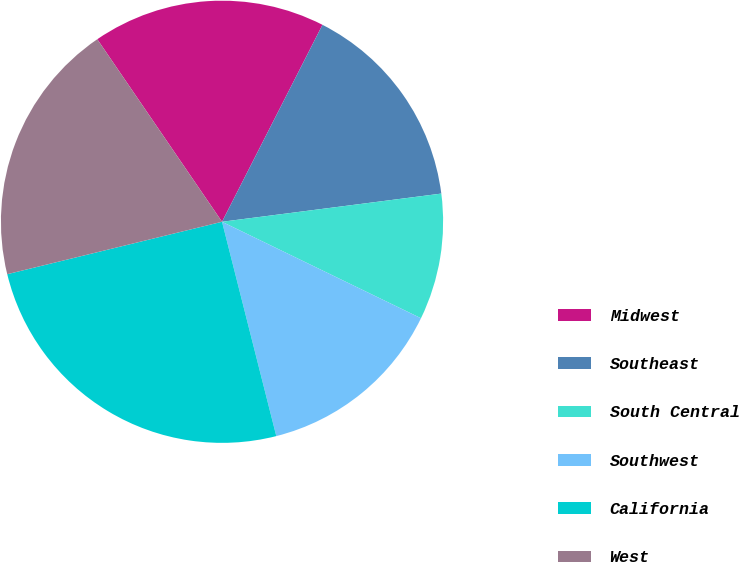<chart> <loc_0><loc_0><loc_500><loc_500><pie_chart><fcel>Midwest<fcel>Southeast<fcel>South Central<fcel>Southwest<fcel>California<fcel>West<nl><fcel>17.05%<fcel>15.46%<fcel>9.22%<fcel>13.87%<fcel>25.14%<fcel>19.27%<nl></chart> 